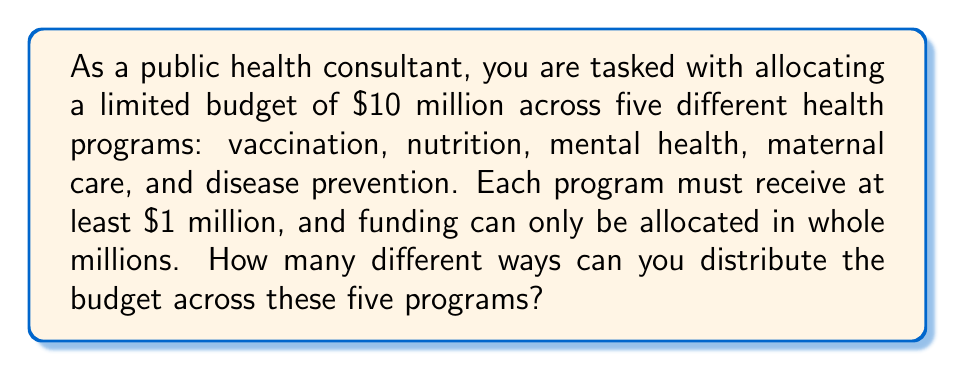Show me your answer to this math problem. This problem can be solved using the concept of combinations with repetition, also known as stars and bars. Here's how we can approach it:

1. We have $10 million to distribute among 5 programs.
2. Each program must receive at least $1 million, so we can start by allocating $1 million to each program. This leaves us with $5 million to distribute.
3. Now, we need to find the number of ways to distribute 5 indistinguishable objects (the remaining $5 million) into 5 distinguishable containers (the programs).

The formula for this scenario is:

$$ \binom{n+k-1}{k-1} $$

Where:
- $n$ is the number of indistinguishable objects (remaining millions to distribute)
- $k$ is the number of distinguishable containers (programs)

In our case:
- $n = 5$ (remaining $5 million)
- $k = 5$ (5 programs)

Plugging these values into the formula:

$$ \binom{5+5-1}{5-1} = \binom{9}{4} $$

To calculate this:

$$ \binom{9}{4} = \frac{9!}{4!(9-4)!} = \frac{9!}{4!5!} $$

$$ = \frac{9 \times 8 \times 7 \times 6 \times 5!}{(4 \times 3 \times 2 \times 1) \times 5!} $$

$$ = \frac{3024}{24} = 126 $$

Therefore, there are 126 different ways to distribute the budget across the five health programs.
Answer: 126 ways 